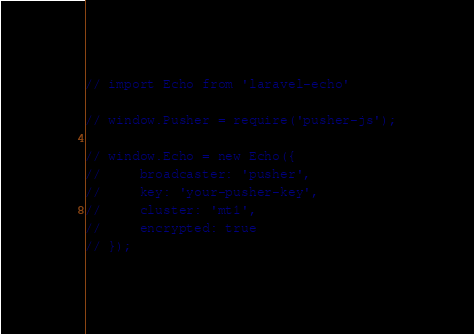Convert code to text. <code><loc_0><loc_0><loc_500><loc_500><_JavaScript_>// import Echo from 'laravel-echo'

// window.Pusher = require('pusher-js');

// window.Echo = new Echo({
//     broadcaster: 'pusher',
//     key: 'your-pusher-key',
//     cluster: 'mt1',
//     encrypted: true
// });
</code> 